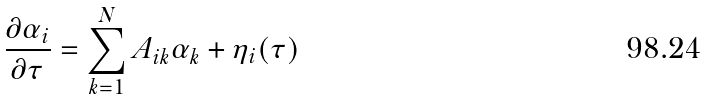<formula> <loc_0><loc_0><loc_500><loc_500>\frac { \partial \alpha _ { i } } { \partial \tau } = \sum _ { k = 1 } ^ { N } A _ { i k } \alpha _ { k } + \eta _ { i } ( \tau )</formula> 